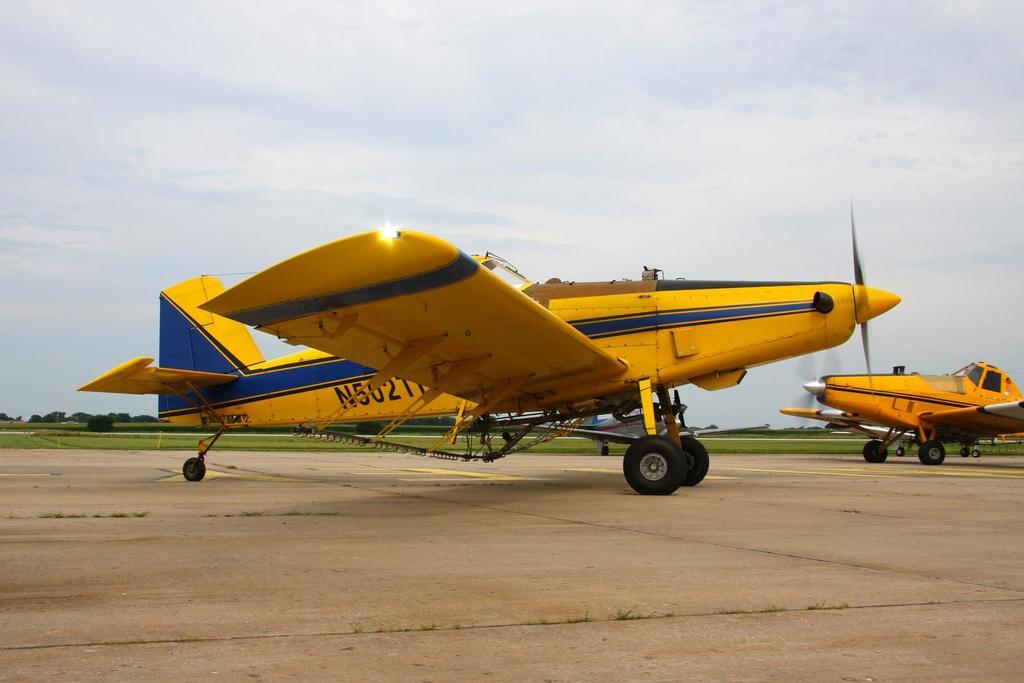What is the tail number on this plane?
Provide a succinct answer. N5027. What color is the plane?
Keep it short and to the point. Answering does not require reading text in the image. 